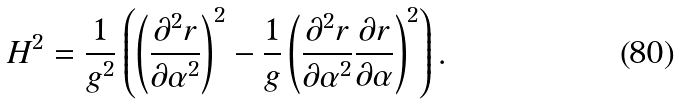Convert formula to latex. <formula><loc_0><loc_0><loc_500><loc_500>H ^ { 2 } = \frac { 1 } { g ^ { 2 } } \left ( \left ( \frac { \partial ^ { 2 } r } { \partial \alpha ^ { 2 } } \right ) ^ { 2 } - \frac { 1 } { g } \left ( \frac { \partial ^ { 2 } r } { \partial \alpha ^ { 2 } } \frac { \partial r } { \partial \alpha } \right ) ^ { 2 } \right ) .</formula> 